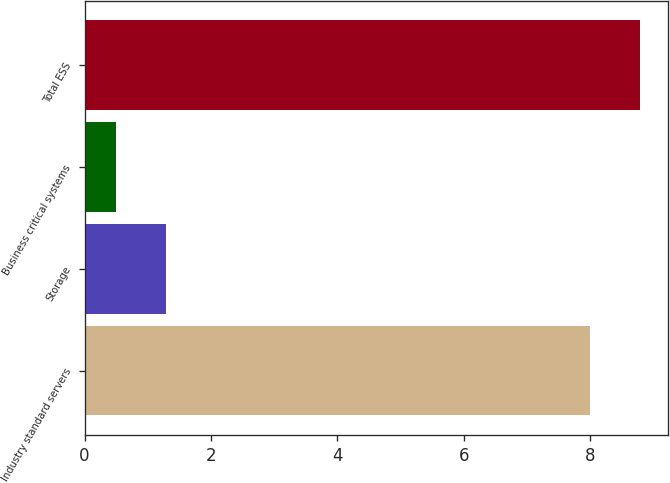<chart> <loc_0><loc_0><loc_500><loc_500><bar_chart><fcel>Industry standard servers<fcel>Storage<fcel>Business critical systems<fcel>Total ESS<nl><fcel>8<fcel>1.29<fcel>0.5<fcel>8.79<nl></chart> 